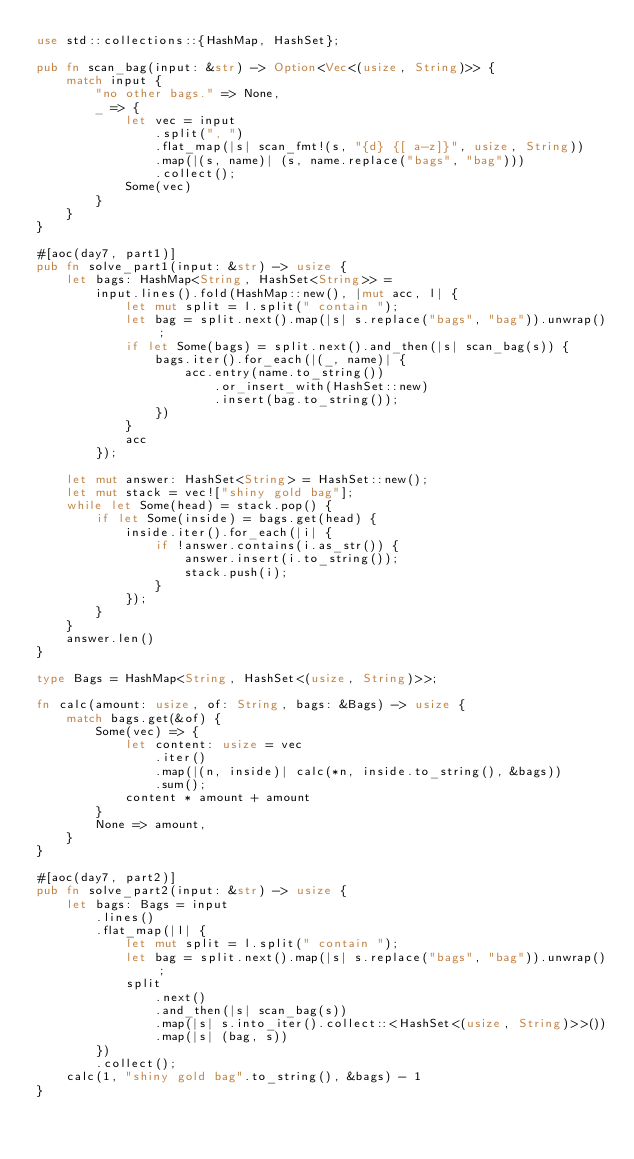<code> <loc_0><loc_0><loc_500><loc_500><_Rust_>use std::collections::{HashMap, HashSet};

pub fn scan_bag(input: &str) -> Option<Vec<(usize, String)>> {
    match input {
        "no other bags." => None,
        _ => {
            let vec = input
                .split(", ")
                .flat_map(|s| scan_fmt!(s, "{d} {[ a-z]}", usize, String))
                .map(|(s, name)| (s, name.replace("bags", "bag")))
                .collect();
            Some(vec)
        }
    }
}

#[aoc(day7, part1)]
pub fn solve_part1(input: &str) -> usize {
    let bags: HashMap<String, HashSet<String>> =
        input.lines().fold(HashMap::new(), |mut acc, l| {
            let mut split = l.split(" contain ");
            let bag = split.next().map(|s| s.replace("bags", "bag")).unwrap();
            if let Some(bags) = split.next().and_then(|s| scan_bag(s)) {
                bags.iter().for_each(|(_, name)| {
                    acc.entry(name.to_string())
                        .or_insert_with(HashSet::new)
                        .insert(bag.to_string());
                })
            }
            acc
        });

    let mut answer: HashSet<String> = HashSet::new();
    let mut stack = vec!["shiny gold bag"];
    while let Some(head) = stack.pop() {
        if let Some(inside) = bags.get(head) {
            inside.iter().for_each(|i| {
                if !answer.contains(i.as_str()) {
                    answer.insert(i.to_string());
                    stack.push(i);
                }
            });
        }
    }
    answer.len()
}

type Bags = HashMap<String, HashSet<(usize, String)>>;

fn calc(amount: usize, of: String, bags: &Bags) -> usize {
    match bags.get(&of) {
        Some(vec) => {
            let content: usize = vec
                .iter()
                .map(|(n, inside)| calc(*n, inside.to_string(), &bags))
                .sum();
            content * amount + amount
        }
        None => amount,
    }
}

#[aoc(day7, part2)]
pub fn solve_part2(input: &str) -> usize {
    let bags: Bags = input
        .lines()
        .flat_map(|l| {
            let mut split = l.split(" contain ");
            let bag = split.next().map(|s| s.replace("bags", "bag")).unwrap();
            split
                .next()
                .and_then(|s| scan_bag(s))
                .map(|s| s.into_iter().collect::<HashSet<(usize, String)>>())
                .map(|s| (bag, s))
        })
        .collect();
    calc(1, "shiny gold bag".to_string(), &bags) - 1
}
</code> 